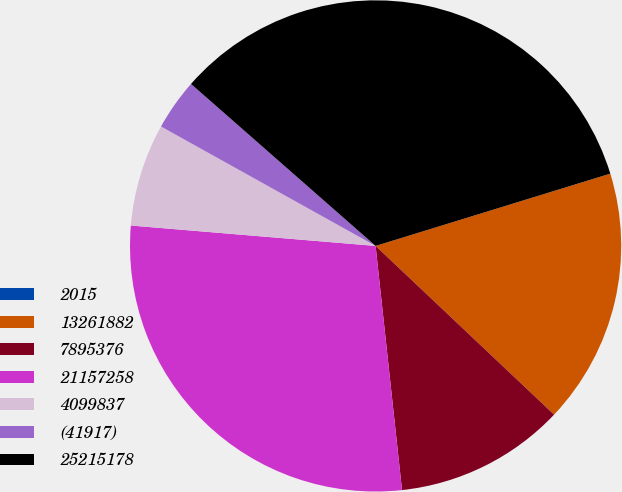<chart> <loc_0><loc_0><loc_500><loc_500><pie_chart><fcel>2015<fcel>13261882<fcel>7895376<fcel>21157258<fcel>4099837<fcel>(41917)<fcel>25215178<nl><fcel>0.0%<fcel>16.81%<fcel>11.23%<fcel>28.04%<fcel>6.76%<fcel>3.38%<fcel>33.78%<nl></chart> 